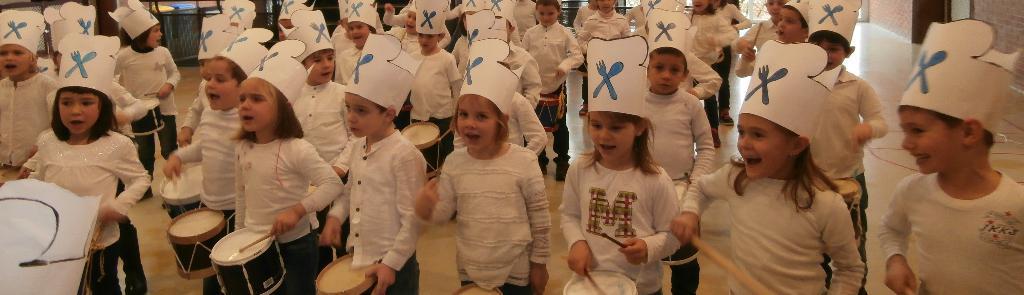Can you describe this image briefly? In this picture we can see all the boys and girls wearing same attire and white colour caps, playing drums with sticks on the floor. On the background we can see wall. 